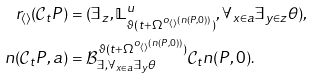<formula> <loc_0><loc_0><loc_500><loc_500>r _ { \langle \rangle } ( \mathcal { C } _ { t } P ) & = ( \exists _ { z } , \mathbb { L } _ { \vartheta ( t + \Omega ^ { o _ { \langle \rangle } ( n ( P , 0 ) ) } ) } ^ { u } , \forall _ { x \in a } \exists _ { y \in z } \theta ) , \\ n ( \mathcal { C } _ { t } P , a ) & = \mathcal { B } _ { \exists , \forall _ { x \in a } \exists _ { y } \theta } ^ { \vartheta ( t + \Omega ^ { o _ { \langle \rangle } ( n ( P , 0 ) ) } ) } \mathcal { C } _ { t } n ( P , 0 ) .</formula> 